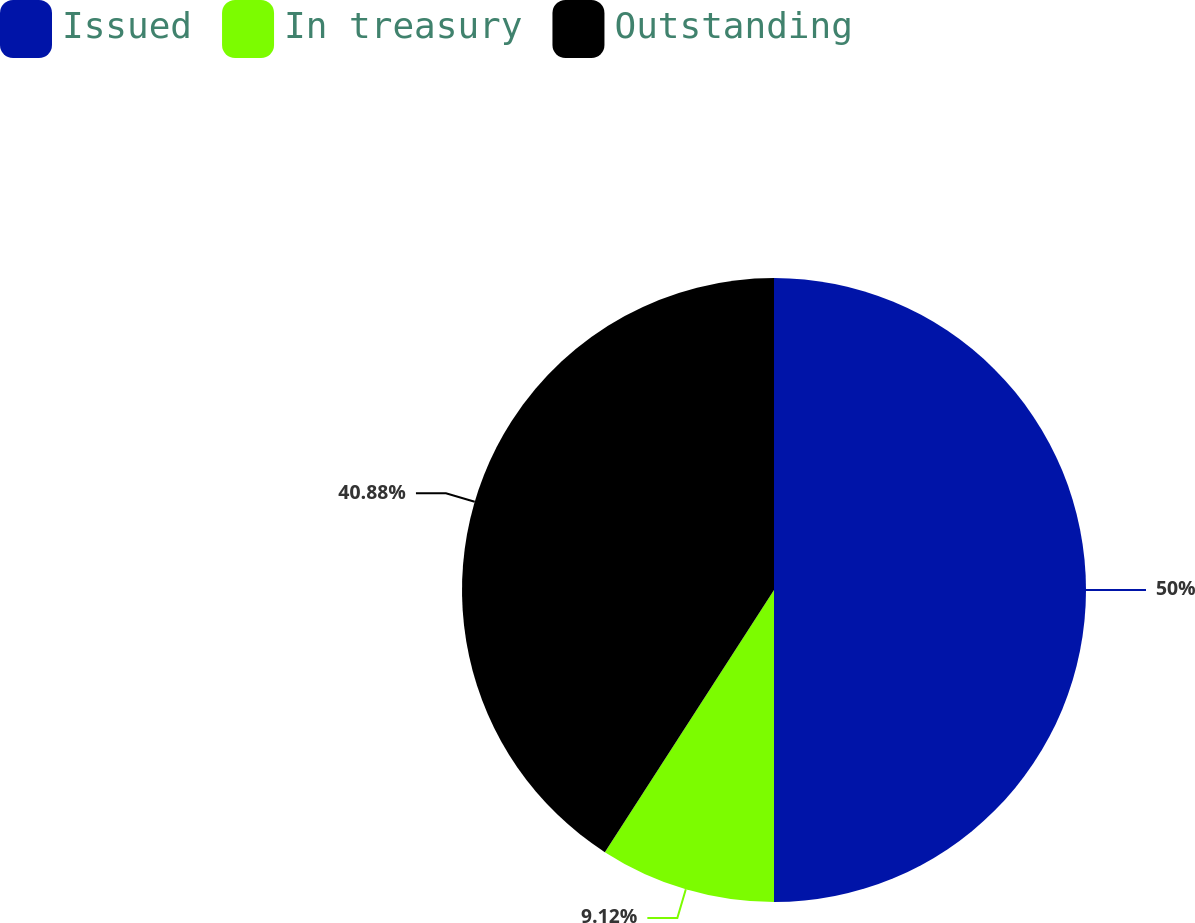<chart> <loc_0><loc_0><loc_500><loc_500><pie_chart><fcel>Issued<fcel>In treasury<fcel>Outstanding<nl><fcel>50.0%<fcel>9.12%<fcel>40.88%<nl></chart> 